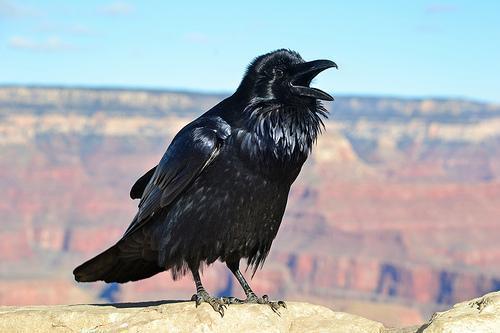How many birds?
Give a very brief answer. 1. 